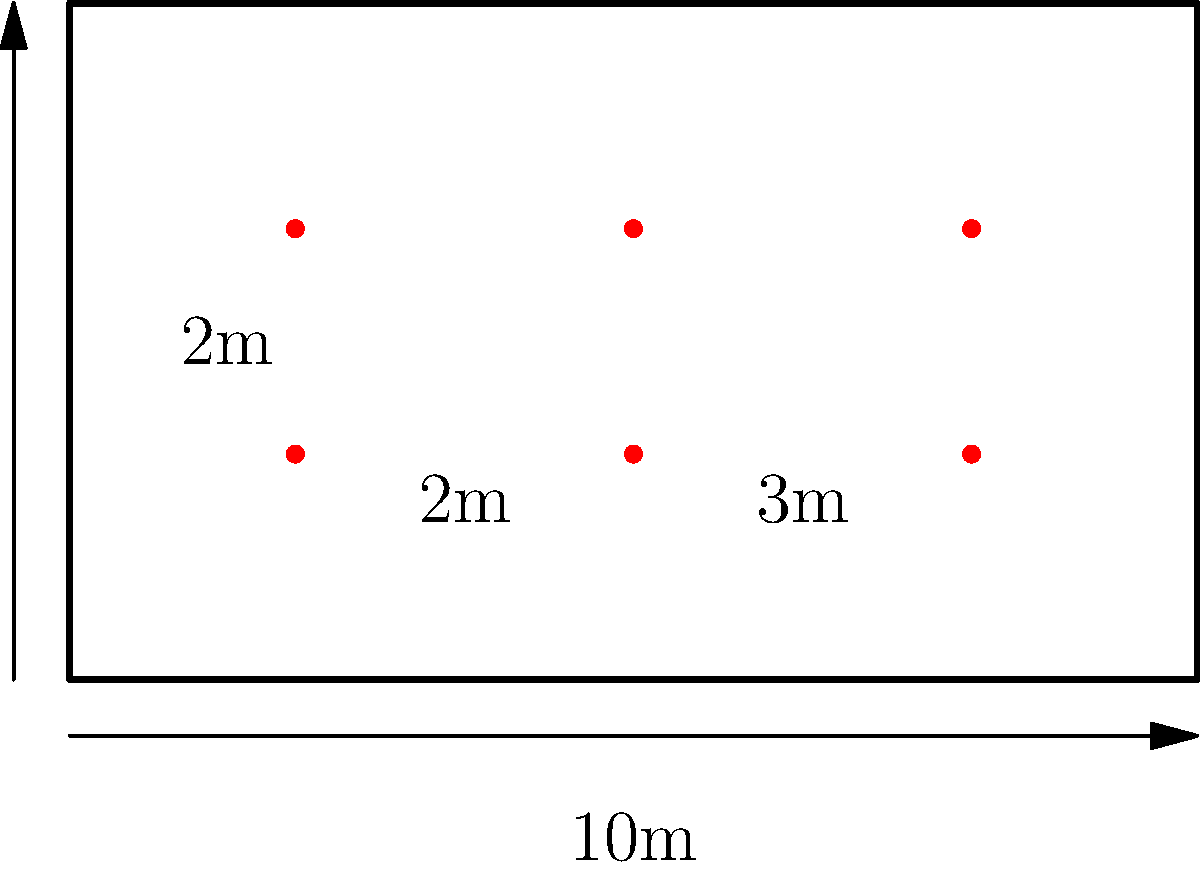As a plant influencer, you're designing a garden layout for a rectangular plot measuring 10m by 6m. You want to create a grid of plants with equal spacing between rows and columns. If you place plants 2m apart in rows and 2m apart in columns, with the outer plants 1m from the edges, how many plants can you fit in this garden? Let's approach this step-by-step:

1. Calculate the number of plants that can fit horizontally:
   - The plot is 10m wide
   - We need 1m on each side, so we have 8m for plants
   - With 2m spacing, we can fit: $8 \div 2 + 1 = 5$ plants horizontally

2. Calculate the number of plants that can fit vertically:
   - The plot is 6m deep
   - We need 1m on each side, so we have 4m for plants
   - With 2m spacing, we can fit: $4 \div 2 + 1 = 3$ plants vertically

3. Calculate the total number of plants:
   - Total plants = Horizontal plants × Vertical plants
   - Total plants = $5 \times 3 = 15$

Therefore, you can fit 15 plants in this garden layout with the given spacing.
Answer: 15 plants 